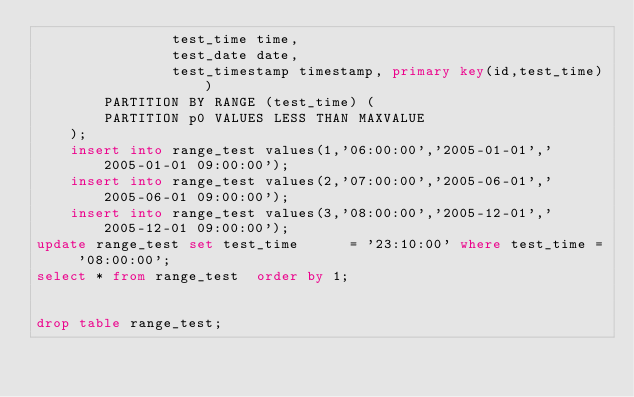<code> <loc_0><loc_0><loc_500><loc_500><_SQL_>				test_time time,
				test_date date,
				test_timestamp timestamp, primary key(id,test_time))
		PARTITION BY RANGE (test_time) (
		PARTITION p0 VALUES LESS THAN MAXVALUE
	);
	insert into range_test values(1,'06:00:00','2005-01-01','2005-01-01 09:00:00');
	insert into range_test values(2,'07:00:00','2005-06-01','2005-06-01 09:00:00');
	insert into range_test values(3,'08:00:00','2005-12-01','2005-12-01 09:00:00');
update range_test set test_time      = '23:10:00' where test_time = '08:00:00';
select * from range_test  order by 1;


drop table range_test;
</code> 